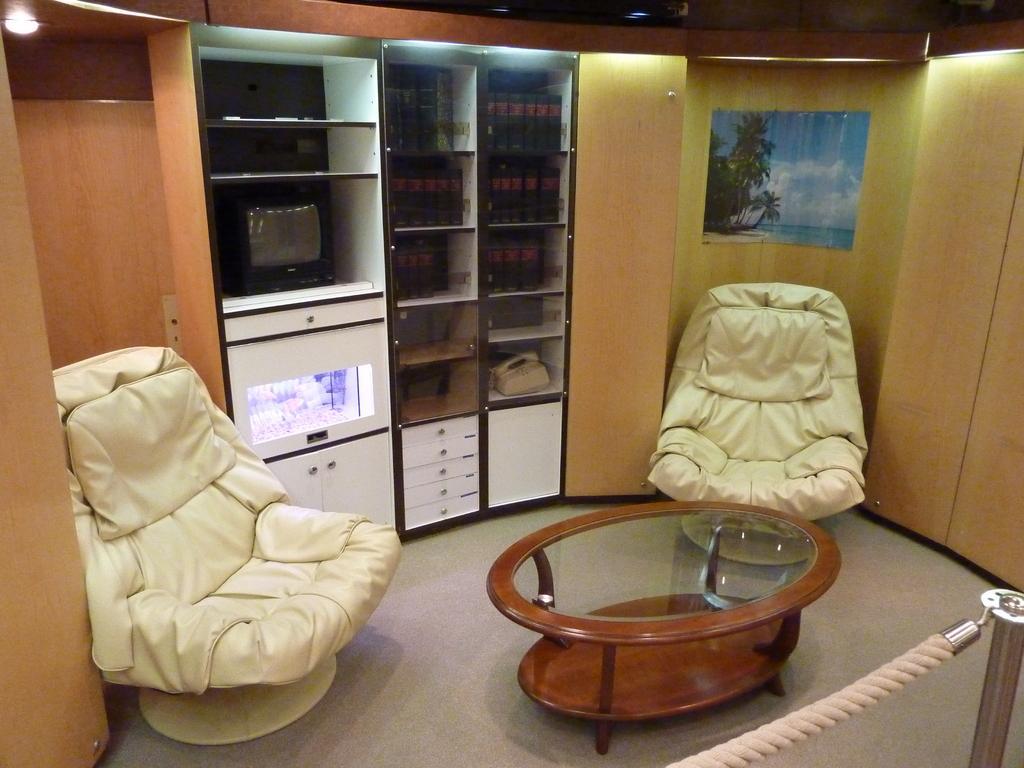Can you describe this image briefly? There are chairs and a table present at the bottom of this image. We can see a television in a cupboard and there is a wooden wall in the background, we can see a photo attached to it. 